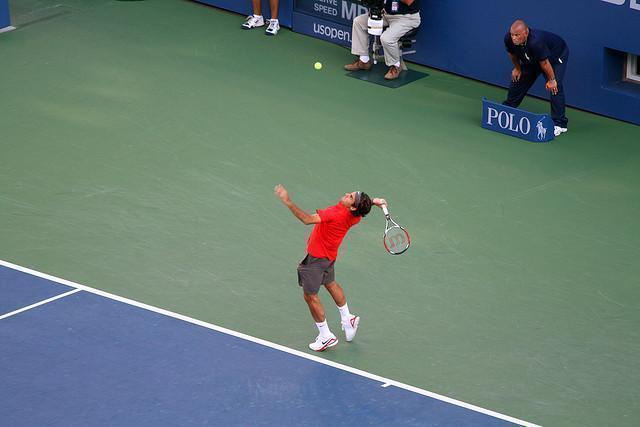What part of tennis is happening?
Choose the right answer and clarify with the format: 'Answer: answer
Rationale: rationale.'
Options: Serve, side spin, block, backhand. Answer: serve.
Rationale: The man is serving. 